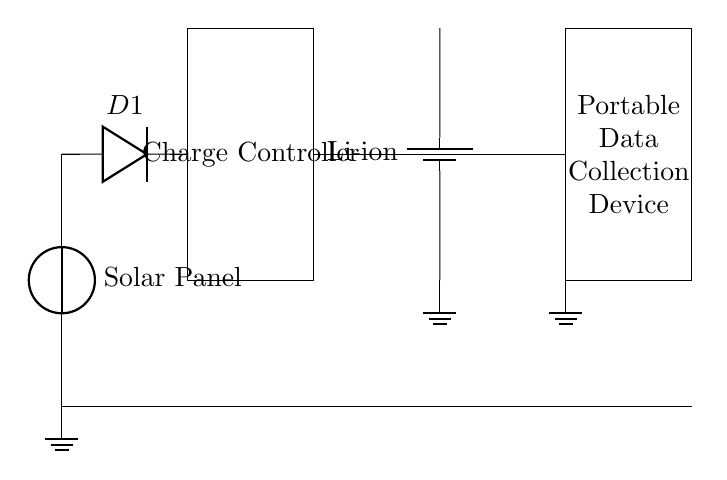What does the circuit primarily charge? The circuit primarily charges a lithium-ion battery, as indicated by the component labeled "Li-ion". This is the main storage element for energy collected from the solar panel.
Answer: lithium-ion battery What component protects the battery from reverse current? The diode labeled "D1" serves this function. It allows current to flow towards the battery while preventing any reverse current that could discharge the battery when there is insufficient solar energy.
Answer: Diode What is the role of the charge controller? The charge controller is responsible for managing the energy flow from the solar panel to the battery, ensuring that charging is done efficiently and protecting the battery from overcharging or excessive discharging. This is essential for maintaining battery health.
Answer: Managing energy flow What type of device is connected to the battery? The device connected to the battery is a portable data collection device, indicated by the respective label in the diagram, emphasizing its role in agricultural data collection.
Answer: Portable data collection device How many main components are in the circuit? The circuit contains five main components: the solar panel, the diode, the charge controller, the lithium-ion battery, and the portable data collection device. This shows a simple solar charging setup.
Answer: Five What happens if the solar panel is not receiving sunlight? If the solar panel does not receive sunlight, it will not generate voltage, and therefore, no current will flow to charge the battery or power the connected device, potentially leading to device shutdown if not supported by an alternate power source.
Answer: No charging occurs What connection connects the solar panel and the diode? The solar panel and the diode are connected through a direct wire, allowing current generated by the solar panel to flow into the diode for further processing and protection.
Answer: Direct wire connection 